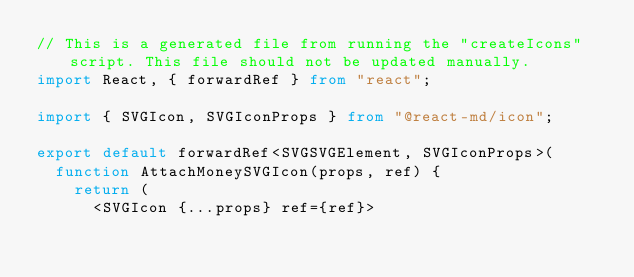<code> <loc_0><loc_0><loc_500><loc_500><_TypeScript_>// This is a generated file from running the "createIcons" script. This file should not be updated manually.
import React, { forwardRef } from "react";

import { SVGIcon, SVGIconProps } from "@react-md/icon";

export default forwardRef<SVGSVGElement, SVGIconProps>(
  function AttachMoneySVGIcon(props, ref) {
    return (
      <SVGIcon {...props} ref={ref}></code> 